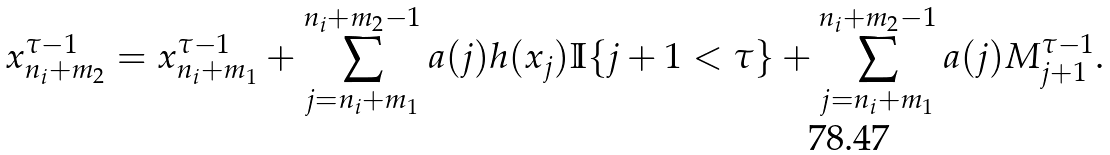<formula> <loc_0><loc_0><loc_500><loc_500>x _ { n _ { i } + m _ { 2 } } ^ { \tau - 1 } = x _ { n _ { i } + m _ { 1 } } ^ { \tau - 1 } + \sum _ { j = n _ { i } + m _ { 1 } } ^ { n _ { i } + m _ { 2 } - 1 } a ( j ) h ( x _ { j } ) \mathbb { I } \{ j + 1 < \tau \} + \sum _ { j = n _ { i } + m _ { 1 } } ^ { n _ { i } + m _ { 2 } - 1 } a ( j ) M _ { j + 1 } ^ { \tau - 1 } .</formula> 